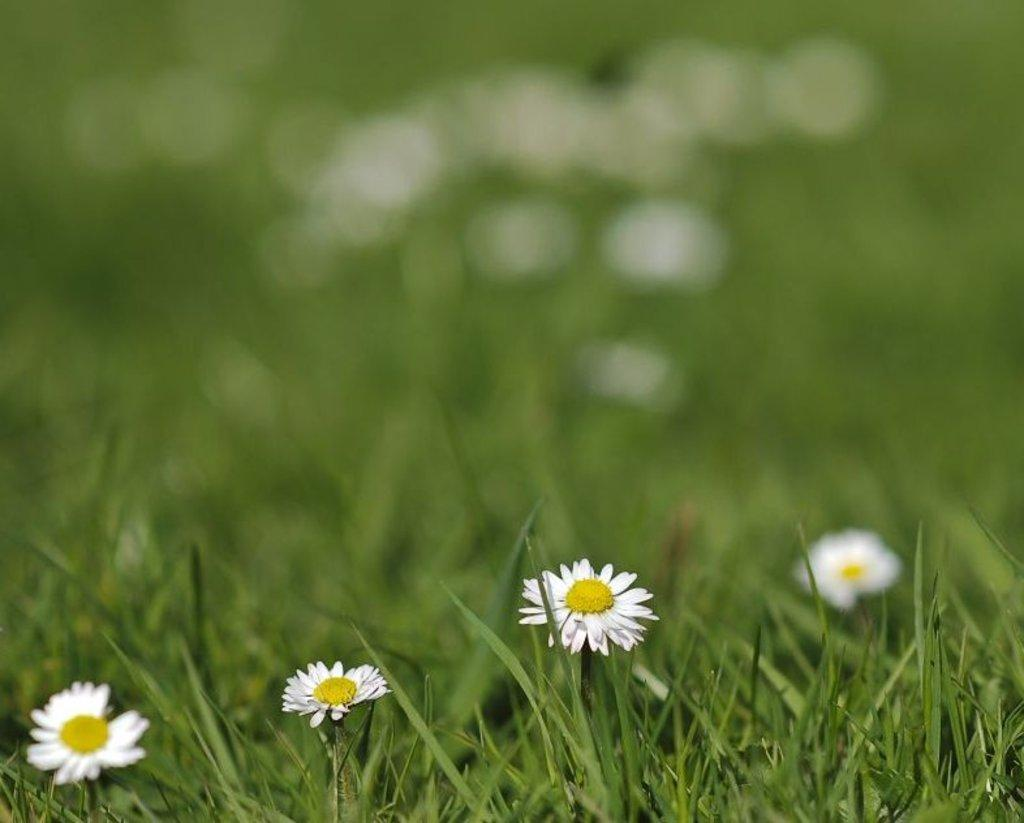How many flowers can be seen in the image? There are four flowers in the image. What type of vegetation is present in the foreground of the image? There is grass in the foreground of the image. What type of marble is visible in the image? There is no marble present in the image; it features four flowers and grass in the foreground. What time of day is depicted in the image? The time of day is not mentioned in the image, so it cannot be determined from the image alone. 